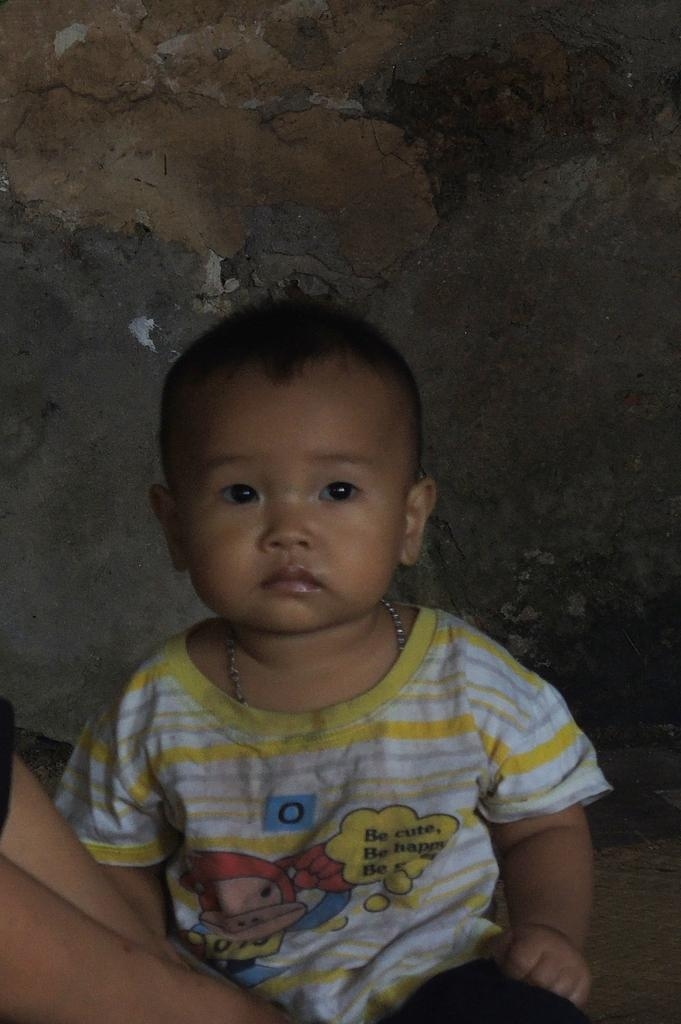What is the main subject in the foreground of the image? There is a kid sitting on the floor in the foreground of the image. Can you describe any other visible elements in the image? There are hands of a person visible on the left bottom of the image. What can be seen in the background of the image? There is a wall in the background of the image. What type of stem can be seen growing from the square in the image? There is no stem or square present in the image. 